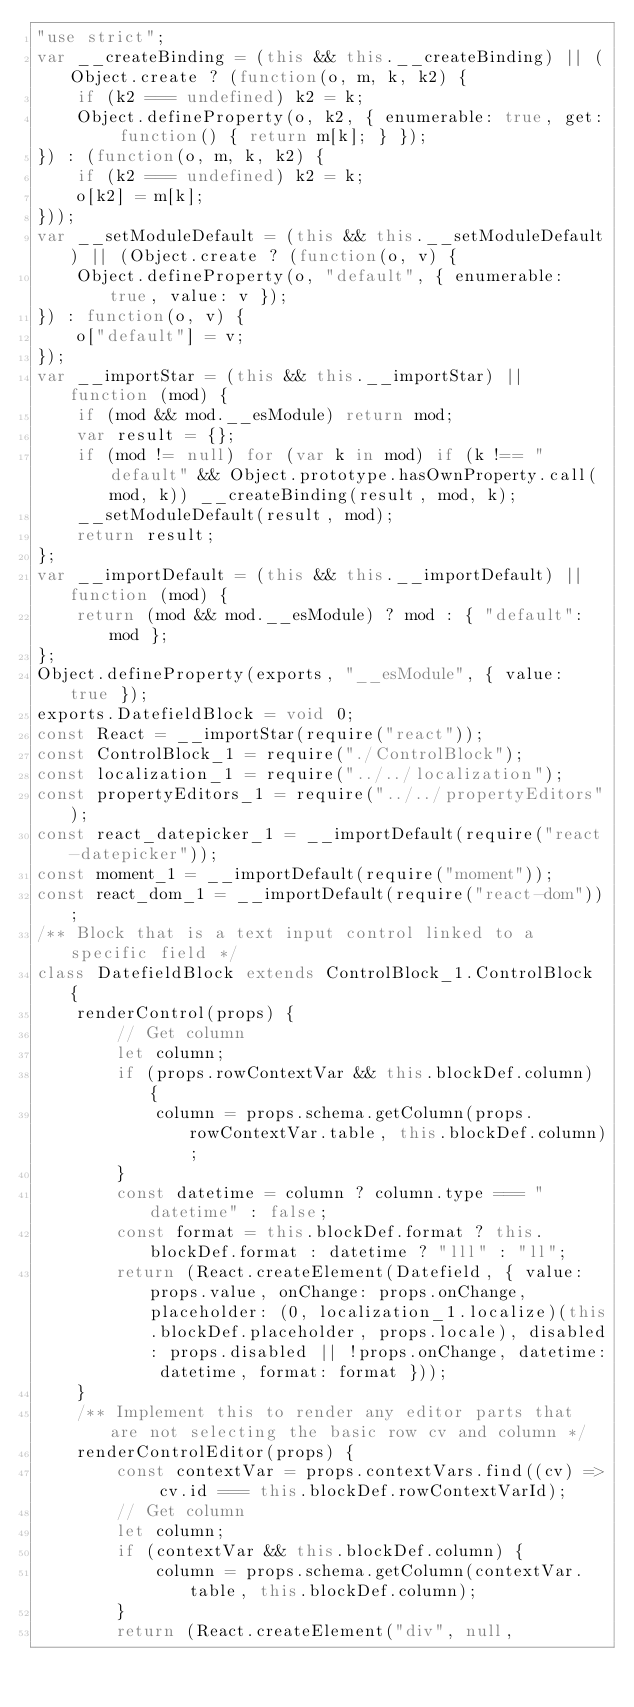Convert code to text. <code><loc_0><loc_0><loc_500><loc_500><_JavaScript_>"use strict";
var __createBinding = (this && this.__createBinding) || (Object.create ? (function(o, m, k, k2) {
    if (k2 === undefined) k2 = k;
    Object.defineProperty(o, k2, { enumerable: true, get: function() { return m[k]; } });
}) : (function(o, m, k, k2) {
    if (k2 === undefined) k2 = k;
    o[k2] = m[k];
}));
var __setModuleDefault = (this && this.__setModuleDefault) || (Object.create ? (function(o, v) {
    Object.defineProperty(o, "default", { enumerable: true, value: v });
}) : function(o, v) {
    o["default"] = v;
});
var __importStar = (this && this.__importStar) || function (mod) {
    if (mod && mod.__esModule) return mod;
    var result = {};
    if (mod != null) for (var k in mod) if (k !== "default" && Object.prototype.hasOwnProperty.call(mod, k)) __createBinding(result, mod, k);
    __setModuleDefault(result, mod);
    return result;
};
var __importDefault = (this && this.__importDefault) || function (mod) {
    return (mod && mod.__esModule) ? mod : { "default": mod };
};
Object.defineProperty(exports, "__esModule", { value: true });
exports.DatefieldBlock = void 0;
const React = __importStar(require("react"));
const ControlBlock_1 = require("./ControlBlock");
const localization_1 = require("../../localization");
const propertyEditors_1 = require("../../propertyEditors");
const react_datepicker_1 = __importDefault(require("react-datepicker"));
const moment_1 = __importDefault(require("moment"));
const react_dom_1 = __importDefault(require("react-dom"));
/** Block that is a text input control linked to a specific field */
class DatefieldBlock extends ControlBlock_1.ControlBlock {
    renderControl(props) {
        // Get column
        let column;
        if (props.rowContextVar && this.blockDef.column) {
            column = props.schema.getColumn(props.rowContextVar.table, this.blockDef.column);
        }
        const datetime = column ? column.type === "datetime" : false;
        const format = this.blockDef.format ? this.blockDef.format : datetime ? "lll" : "ll";
        return (React.createElement(Datefield, { value: props.value, onChange: props.onChange, placeholder: (0, localization_1.localize)(this.blockDef.placeholder, props.locale), disabled: props.disabled || !props.onChange, datetime: datetime, format: format }));
    }
    /** Implement this to render any editor parts that are not selecting the basic row cv and column */
    renderControlEditor(props) {
        const contextVar = props.contextVars.find((cv) => cv.id === this.blockDef.rowContextVarId);
        // Get column
        let column;
        if (contextVar && this.blockDef.column) {
            column = props.schema.getColumn(contextVar.table, this.blockDef.column);
        }
        return (React.createElement("div", null,</code> 